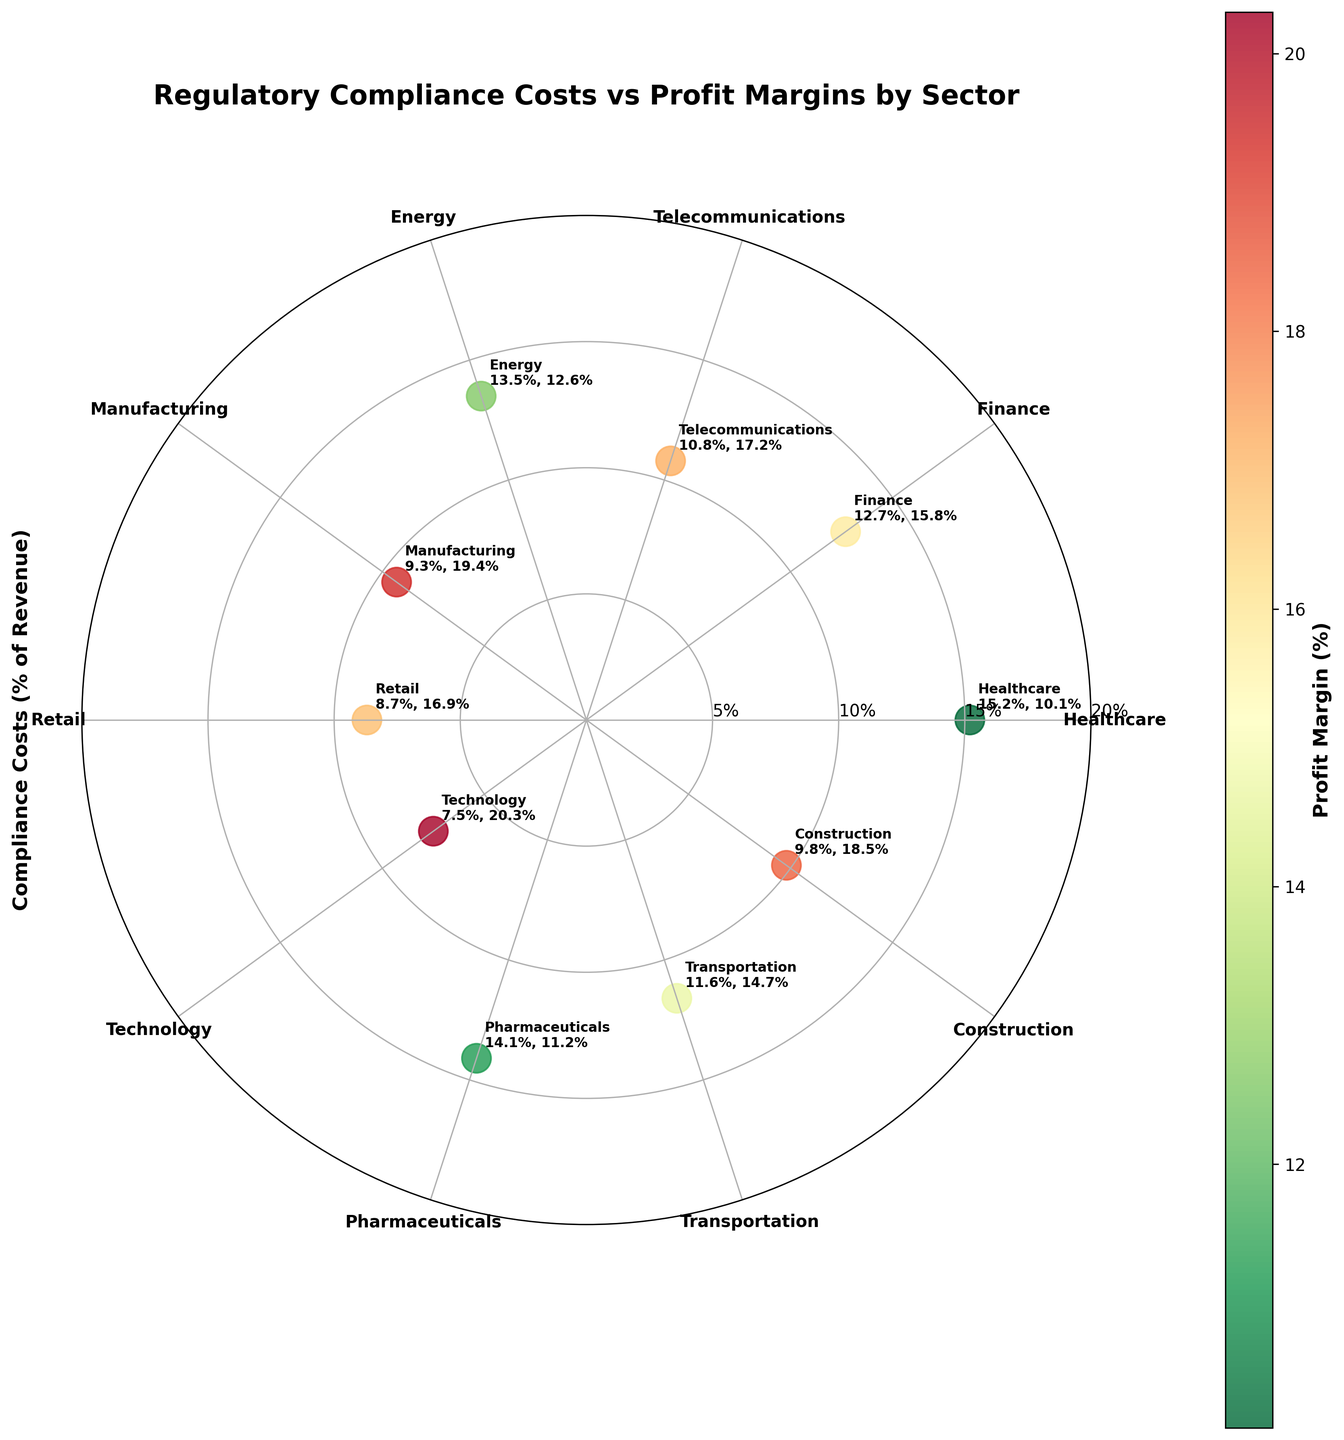What is the overall title of this plot? The title of the plot is usually displayed at the top. In this case, it should be easily visible.
Answer: Regulatory Compliance Costs vs Profit Margins by Sector How many sectors are represented in this plot? You count the number of distinct sectors represented in the polar scatter chart by looking at the labeled points or the xticks.
Answer: 10 Which sector has the highest compliance costs as a percentage of revenue? By looking at the radial position (distance from the center) among the points, the one farthest out represents the highest compliance costs.
Answer: Healthcare Which sector has the highest profit margin? The color bar can help identify which point has the highest color intensity representing the profit margin.
Answer: Technology What is the profit margin for the Healthcare sector? Look for the label or use the color bar to identify the profit margin for the Healthcare sector. It is typically listed next to the point on the chart.
Answer: 10.1% Which sector has the lowest compliance costs as a percentage of revenue? By looking at the radial position (distance from the center), the point closest to the center represents the lowest compliance costs.
Answer: Technology Which sectors have compliance costs that are greater than 10% of revenue? Identify and list the sectors where the radial position is greater than 10% on the polarization axis.
Answer: Healthcare, Finance, Energy, Pharmaceuticals, Transportation Are there any sectors with compliance costs lower than 10% and profit margins higher than 18%? Check the plot for points that are both near the center (less than 10%) and have a high color intensity (profit margins higher than 18%).
Answer: Manufacturing, Construction What's the average compliance cost percentage for all sectors? Add up the compliance costs percentages for all sectors and divide by the number of sectors to get the average. \( (15.2 + 12.7 + 10.8 + 13.5 + 9.3 + 8.7 + 7.5 + 14.1 + 11.6 + 9.8) / 10 = 11.32 \)
Answer: 11.32% Is there a correlation between higher compliance costs and lower profit margins? Compare the position of points (compliance costs) with their color (profit margins). If higher costs generally correspond to less intense color, it indicates a negative correlation.
Answer: Yes 